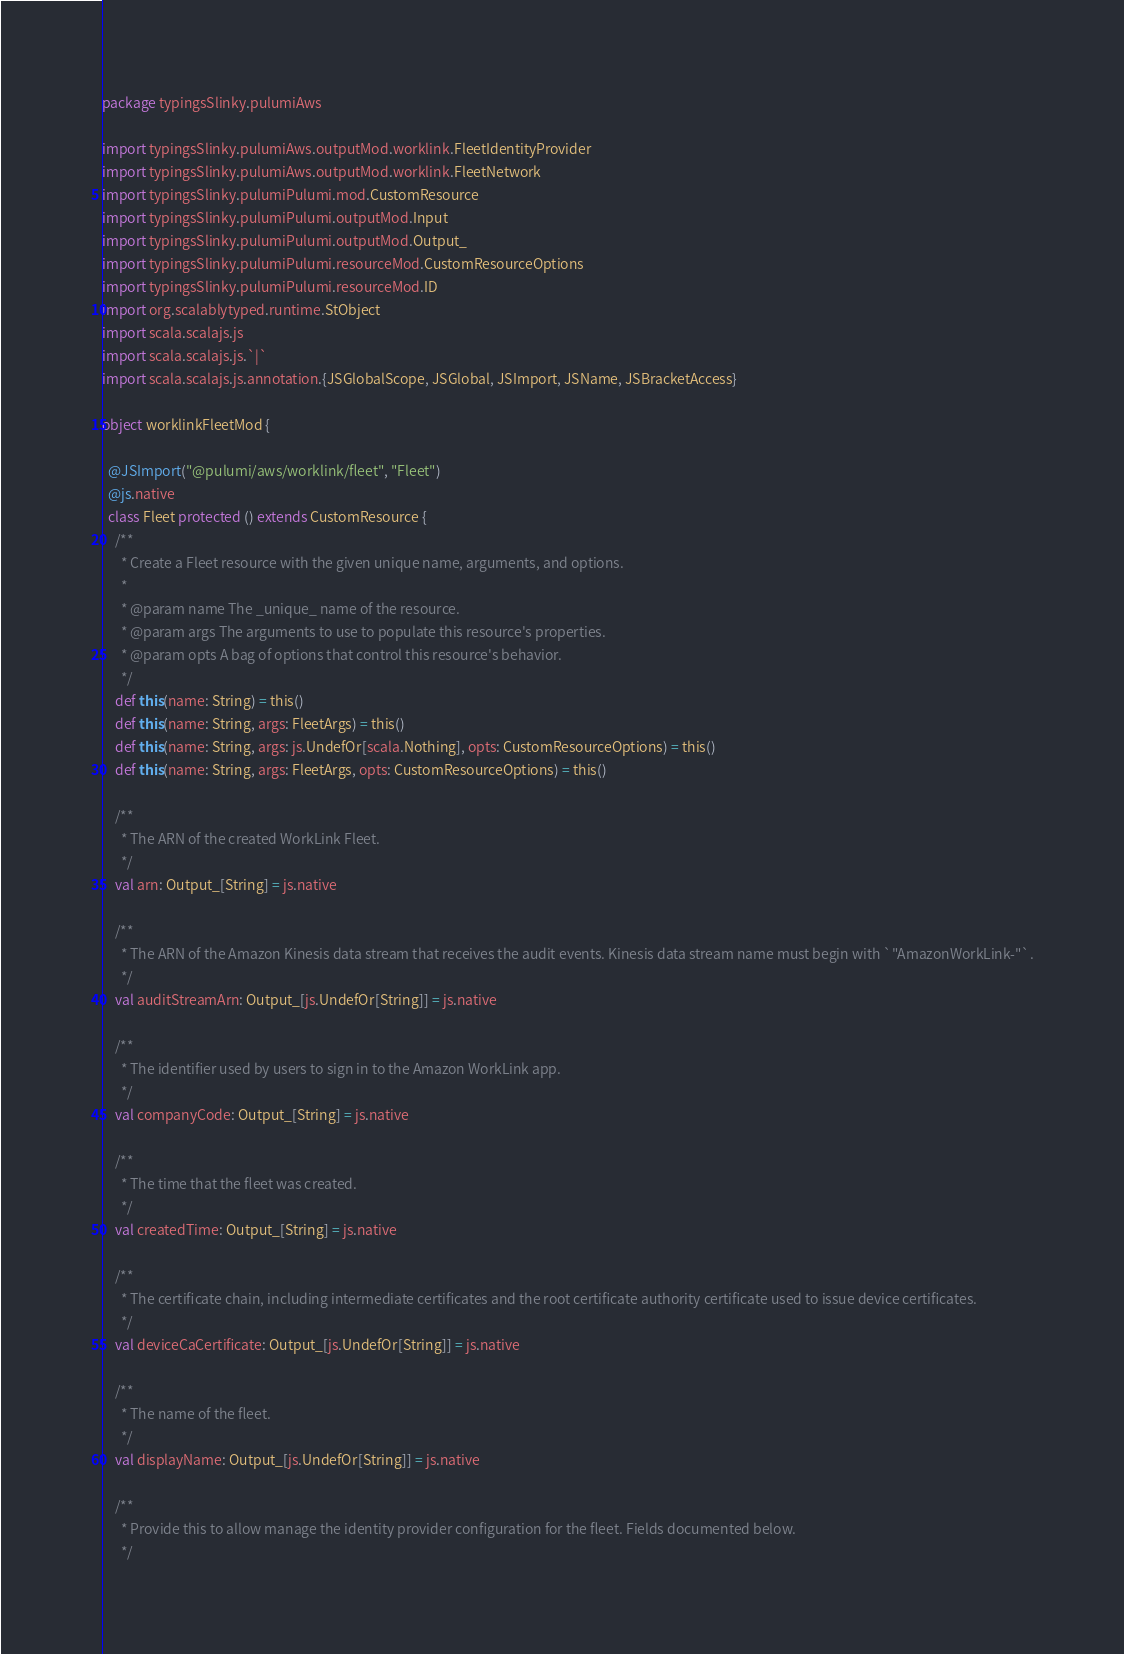<code> <loc_0><loc_0><loc_500><loc_500><_Scala_>package typingsSlinky.pulumiAws

import typingsSlinky.pulumiAws.outputMod.worklink.FleetIdentityProvider
import typingsSlinky.pulumiAws.outputMod.worklink.FleetNetwork
import typingsSlinky.pulumiPulumi.mod.CustomResource
import typingsSlinky.pulumiPulumi.outputMod.Input
import typingsSlinky.pulumiPulumi.outputMod.Output_
import typingsSlinky.pulumiPulumi.resourceMod.CustomResourceOptions
import typingsSlinky.pulumiPulumi.resourceMod.ID
import org.scalablytyped.runtime.StObject
import scala.scalajs.js
import scala.scalajs.js.`|`
import scala.scalajs.js.annotation.{JSGlobalScope, JSGlobal, JSImport, JSName, JSBracketAccess}

object worklinkFleetMod {
  
  @JSImport("@pulumi/aws/worklink/fleet", "Fleet")
  @js.native
  class Fleet protected () extends CustomResource {
    /**
      * Create a Fleet resource with the given unique name, arguments, and options.
      *
      * @param name The _unique_ name of the resource.
      * @param args The arguments to use to populate this resource's properties.
      * @param opts A bag of options that control this resource's behavior.
      */
    def this(name: String) = this()
    def this(name: String, args: FleetArgs) = this()
    def this(name: String, args: js.UndefOr[scala.Nothing], opts: CustomResourceOptions) = this()
    def this(name: String, args: FleetArgs, opts: CustomResourceOptions) = this()
    
    /**
      * The ARN of the created WorkLink Fleet.
      */
    val arn: Output_[String] = js.native
    
    /**
      * The ARN of the Amazon Kinesis data stream that receives the audit events. Kinesis data stream name must begin with `"AmazonWorkLink-"`.
      */
    val auditStreamArn: Output_[js.UndefOr[String]] = js.native
    
    /**
      * The identifier used by users to sign in to the Amazon WorkLink app.
      */
    val companyCode: Output_[String] = js.native
    
    /**
      * The time that the fleet was created.
      */
    val createdTime: Output_[String] = js.native
    
    /**
      * The certificate chain, including intermediate certificates and the root certificate authority certificate used to issue device certificates.
      */
    val deviceCaCertificate: Output_[js.UndefOr[String]] = js.native
    
    /**
      * The name of the fleet.
      */
    val displayName: Output_[js.UndefOr[String]] = js.native
    
    /**
      * Provide this to allow manage the identity provider configuration for the fleet. Fields documented below.
      */</code> 